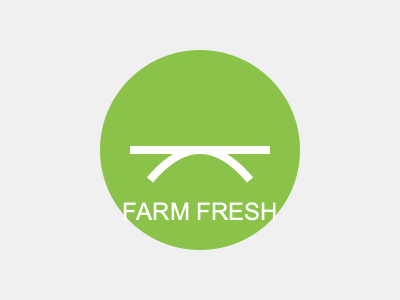As a graphic designer, you're tasked with creating a logo for a new farm-to-table initiative. The client wants a simple, memorable design that incorporates circular elements and emphasizes freshness. Based on the provided logo concept, what key principle of logo design is most prominently demonstrated? To answer this question, let's analyze the key elements of the logo and relate them to fundamental principles of logo design:

1. Shape: The logo uses a circular shape as its primary element, which is simple and easy to remember.

2. Color: The green color (#8bc34a) is associated with freshness, nature, and growth, aligning with the farm-to-table concept.

3. Typography: The text "FARM FRESH" is clear and legible, using a sans-serif font that complements the circular design.

4. Symbolism: The white curves inside the circle suggest a simplified representation of hills or plant growth, reinforcing the farming theme.

5. Simplicity: The overall design is uncomplicated, using minimal elements to convey the message.

6. Scalability: The logo's simple design would work well at various sizes, from small applications to large displays.

7. Versatility: The design could easily be adapted to different color schemes or backgrounds if needed.

8. Memorability: The combination of the circular shape, simple curves, and clear text creates a distinctive and memorable image.

Among these principles, the most prominently demonstrated is simplicity. The logo uses minimal elements (a circle, two curved lines, and text) to create a clear and impactful design that effectively communicates the farm-to-table concept.
Answer: Simplicity 